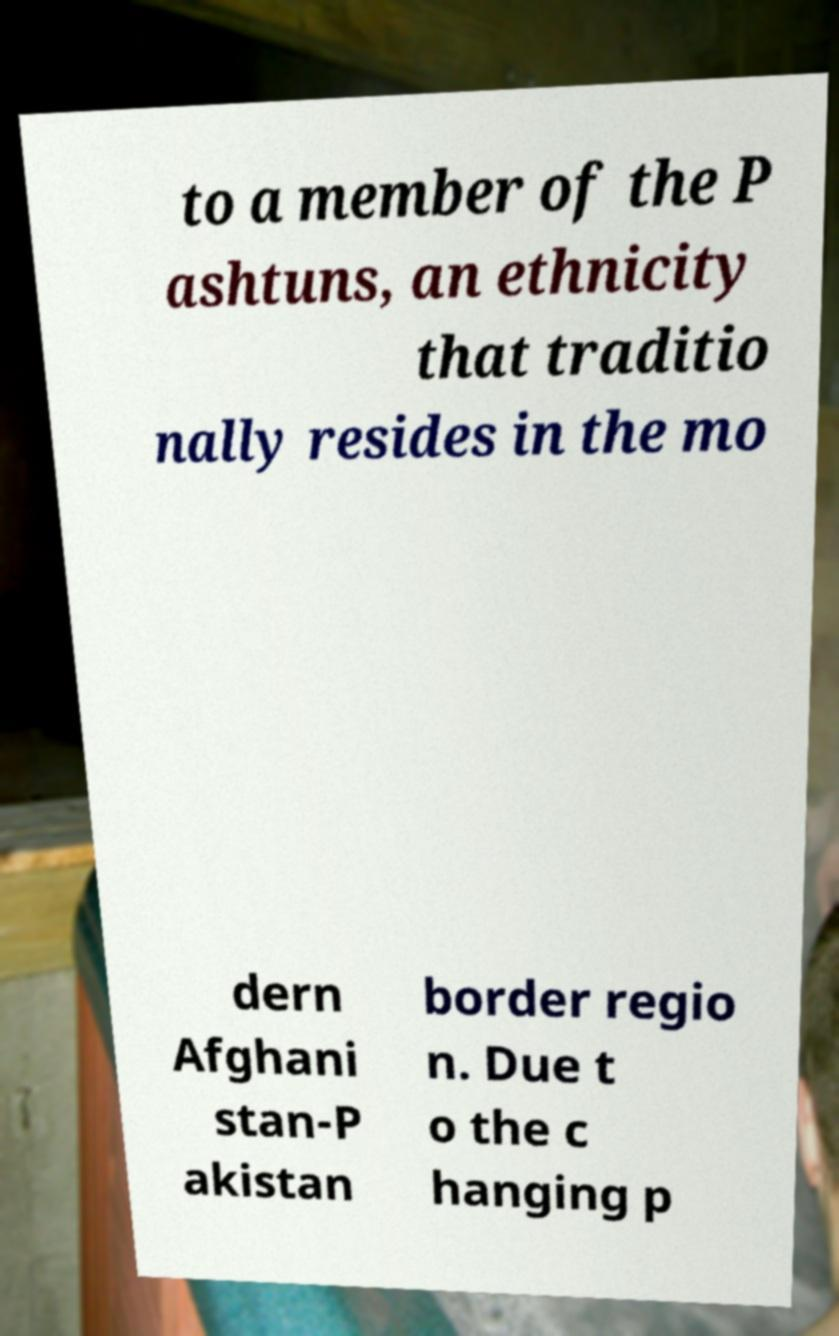Can you read and provide the text displayed in the image?This photo seems to have some interesting text. Can you extract and type it out for me? to a member of the P ashtuns, an ethnicity that traditio nally resides in the mo dern Afghani stan-P akistan border regio n. Due t o the c hanging p 